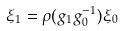Convert formula to latex. <formula><loc_0><loc_0><loc_500><loc_500>\xi _ { 1 } = \rho ( g _ { 1 } g ^ { - 1 } _ { 0 } ) \xi _ { 0 }</formula> 